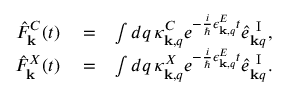Convert formula to latex. <formula><loc_0><loc_0><loc_500><loc_500>\begin{array} { r l r } { \hat { F } _ { k } ^ { C } ( t ) } & = } & { \int d q \, \kappa _ { { k } , q } ^ { C } e ^ { - \frac { i } { } \epsilon _ { { k } , q } ^ { E } t } \hat { e } _ { { k } q } ^ { I } , } \\ { \hat { F } _ { k } ^ { X } ( t ) } & = } & { \int d q \, \kappa _ { { k } , q } ^ { X } e ^ { - \frac { i } { } \epsilon _ { { k } , q } ^ { E } t } \hat { e } _ { { k } q } ^ { I } . } \end{array}</formula> 